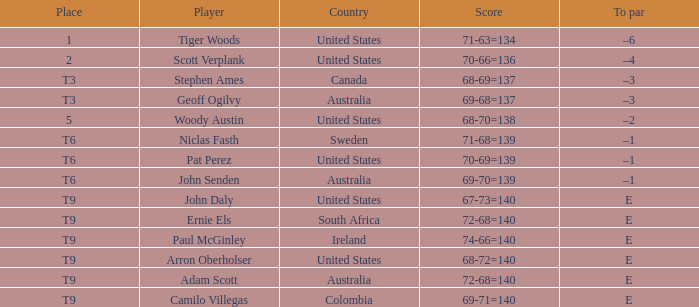What is Canada's score? 68-69=137. 